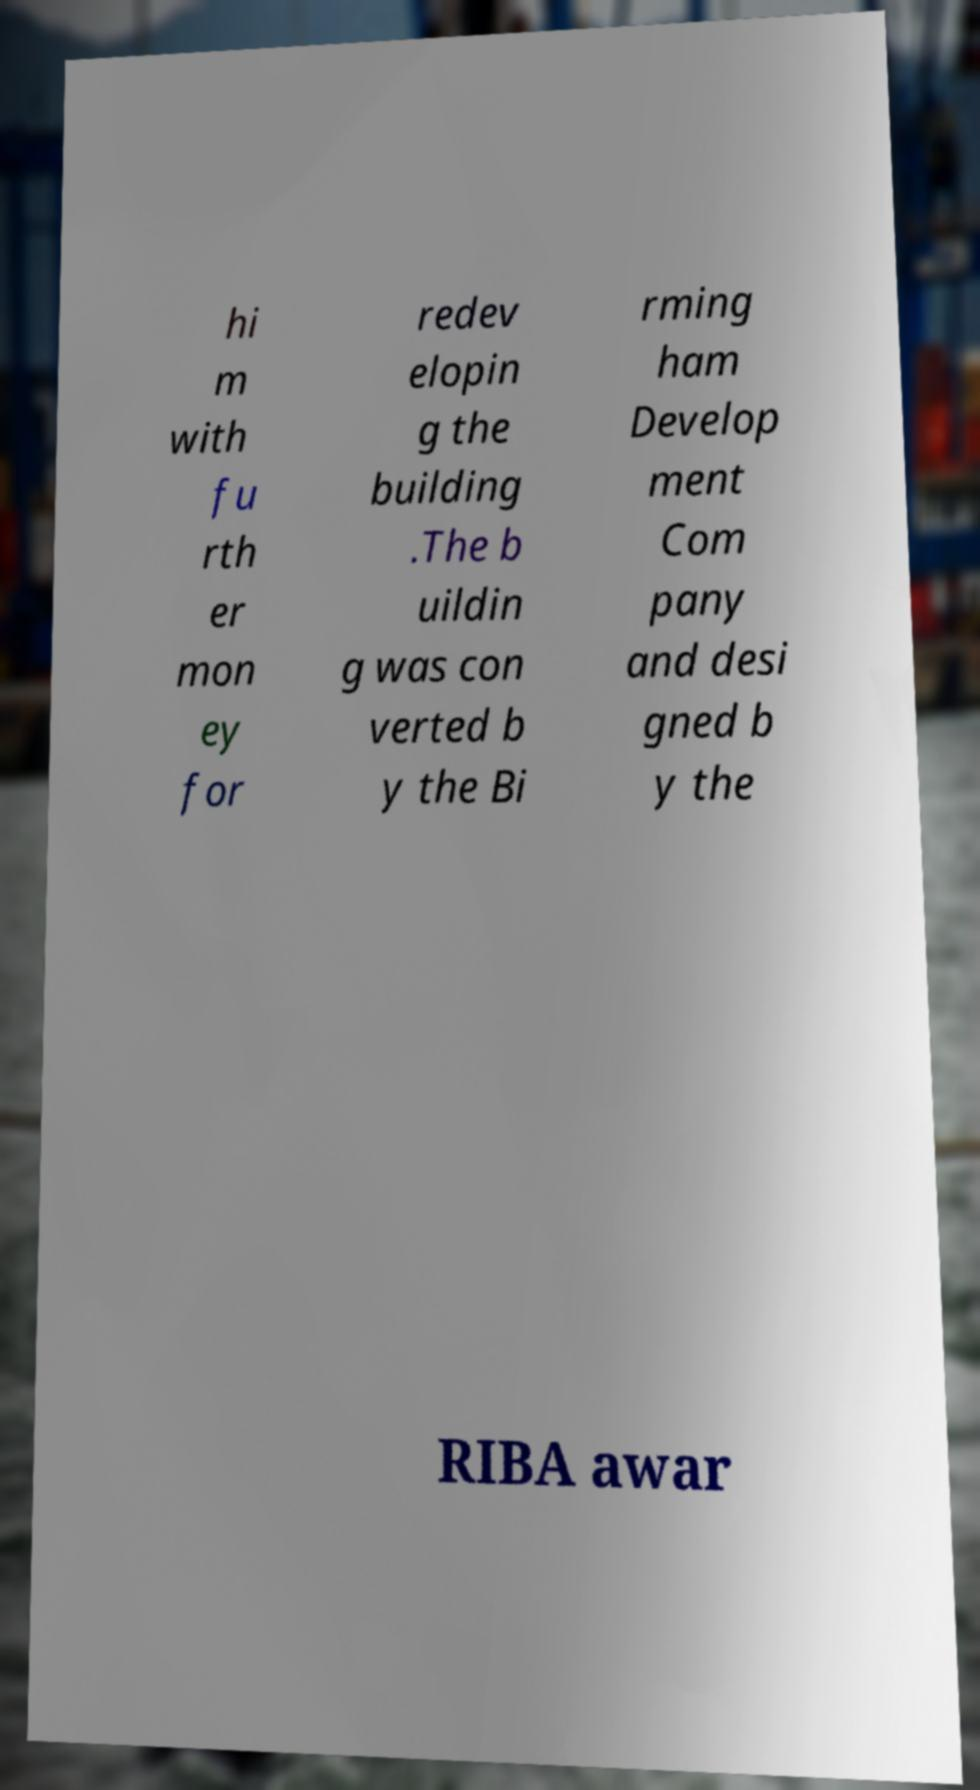Could you extract and type out the text from this image? hi m with fu rth er mon ey for redev elopin g the building .The b uildin g was con verted b y the Bi rming ham Develop ment Com pany and desi gned b y the RIBA awar 